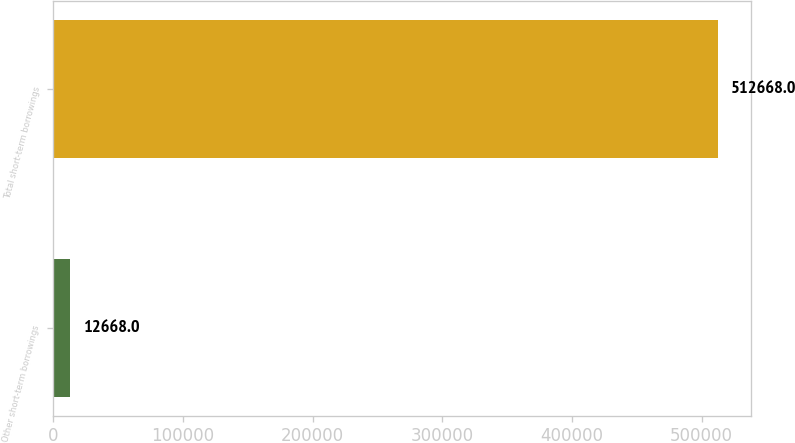Convert chart. <chart><loc_0><loc_0><loc_500><loc_500><bar_chart><fcel>Other short-term borrowings<fcel>Total short-term borrowings<nl><fcel>12668<fcel>512668<nl></chart> 